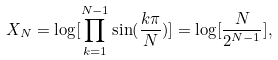<formula> <loc_0><loc_0><loc_500><loc_500>X _ { N } = \log [ \prod _ { k = 1 } ^ { N - 1 } \sin ( \frac { k \pi } { N } ) ] = \log [ \frac { N } { 2 ^ { N - 1 } } ] ,</formula> 